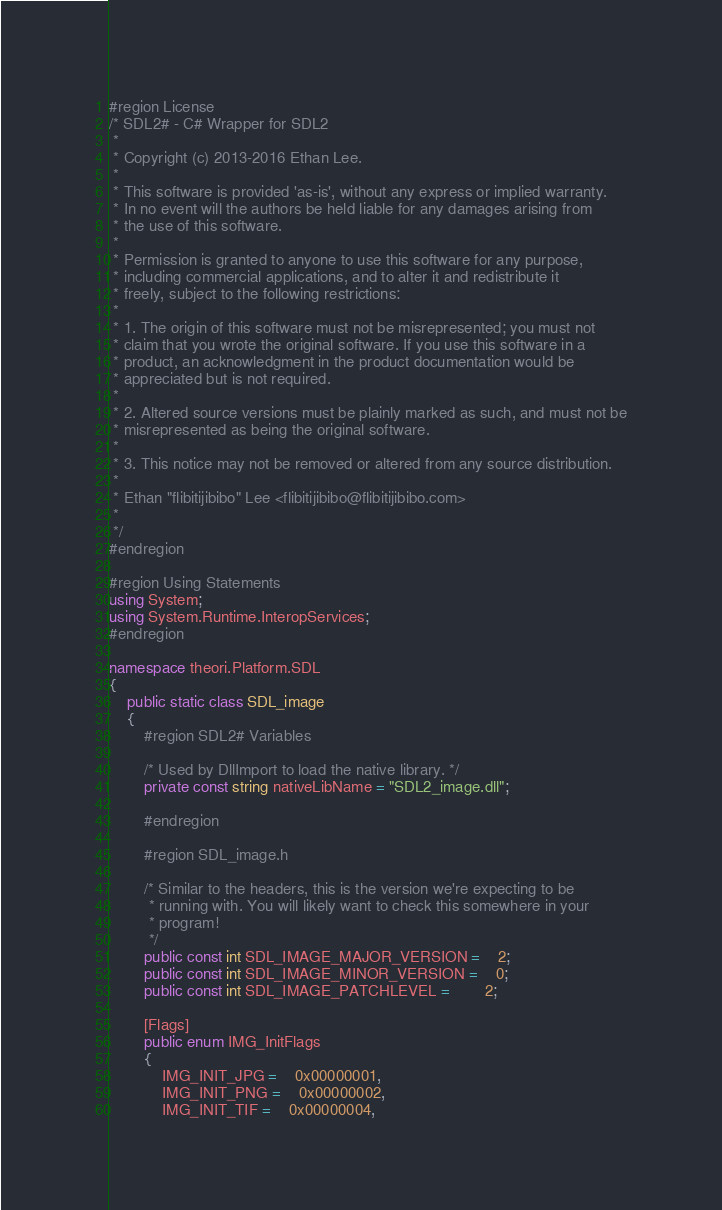<code> <loc_0><loc_0><loc_500><loc_500><_C#_>#region License
/* SDL2# - C# Wrapper for SDL2
 *
 * Copyright (c) 2013-2016 Ethan Lee.
 *
 * This software is provided 'as-is', without any express or implied warranty.
 * In no event will the authors be held liable for any damages arising from
 * the use of this software.
 *
 * Permission is granted to anyone to use this software for any purpose,
 * including commercial applications, and to alter it and redistribute it
 * freely, subject to the following restrictions:
 *
 * 1. The origin of this software must not be misrepresented; you must not
 * claim that you wrote the original software. If you use this software in a
 * product, an acknowledgment in the product documentation would be
 * appreciated but is not required.
 *
 * 2. Altered source versions must be plainly marked as such, and must not be
 * misrepresented as being the original software.
 *
 * 3. This notice may not be removed or altered from any source distribution.
 *
 * Ethan "flibitijibibo" Lee <flibitijibibo@flibitijibibo.com>
 *
 */
#endregion

#region Using Statements
using System;
using System.Runtime.InteropServices;
#endregion

namespace theori.Platform.SDL
{
	public static class SDL_image
	{
		#region SDL2# Variables

		/* Used by DllImport to load the native library. */
		private const string nativeLibName = "SDL2_image.dll";

		#endregion

		#region SDL_image.h

		/* Similar to the headers, this is the version we're expecting to be
		 * running with. You will likely want to check this somewhere in your
		 * program!
		 */
		public const int SDL_IMAGE_MAJOR_VERSION =	2;
		public const int SDL_IMAGE_MINOR_VERSION =	0;
		public const int SDL_IMAGE_PATCHLEVEL =		2;

		[Flags]
		public enum IMG_InitFlags
		{
			IMG_INIT_JPG =	0x00000001,
			IMG_INIT_PNG =	0x00000002,
			IMG_INIT_TIF =	0x00000004,</code> 